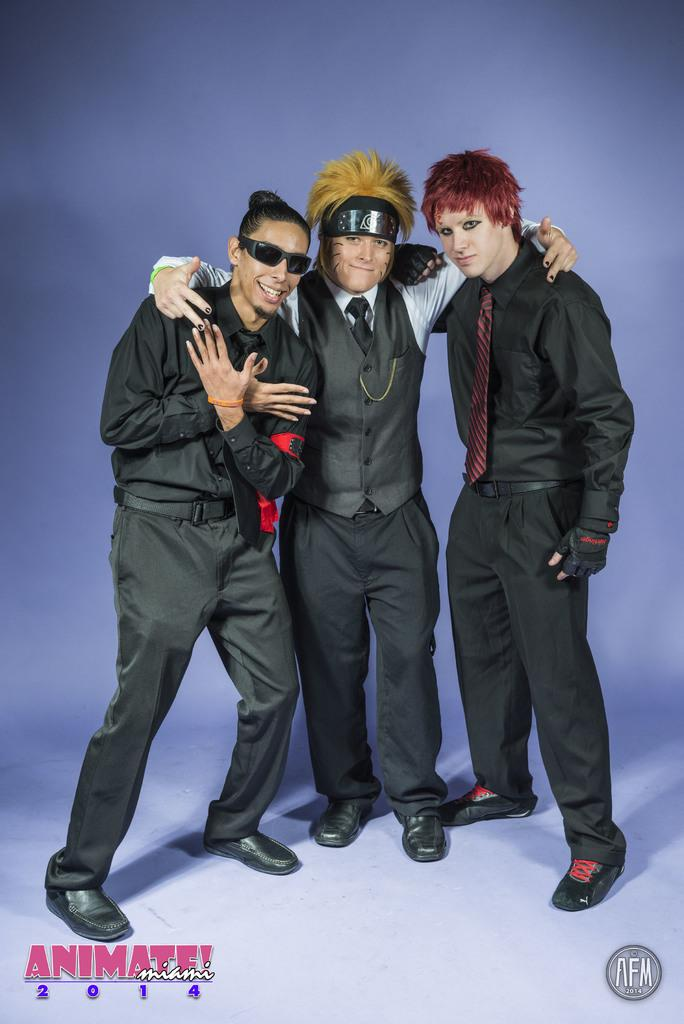What color is the background of the image? The background of the image is blue. What are the people in the image doing? The people in the image are standing and posing. Are there any visible marks or imperfections in the image? Yes, there are water marks at the bottom portion of the image. What type of drain can be seen in the image? There is no drain present in the image. How does the channel affect the taste of the water in the image? There is no channel or water present in the image, so it is not possible to determine any effect on taste. 